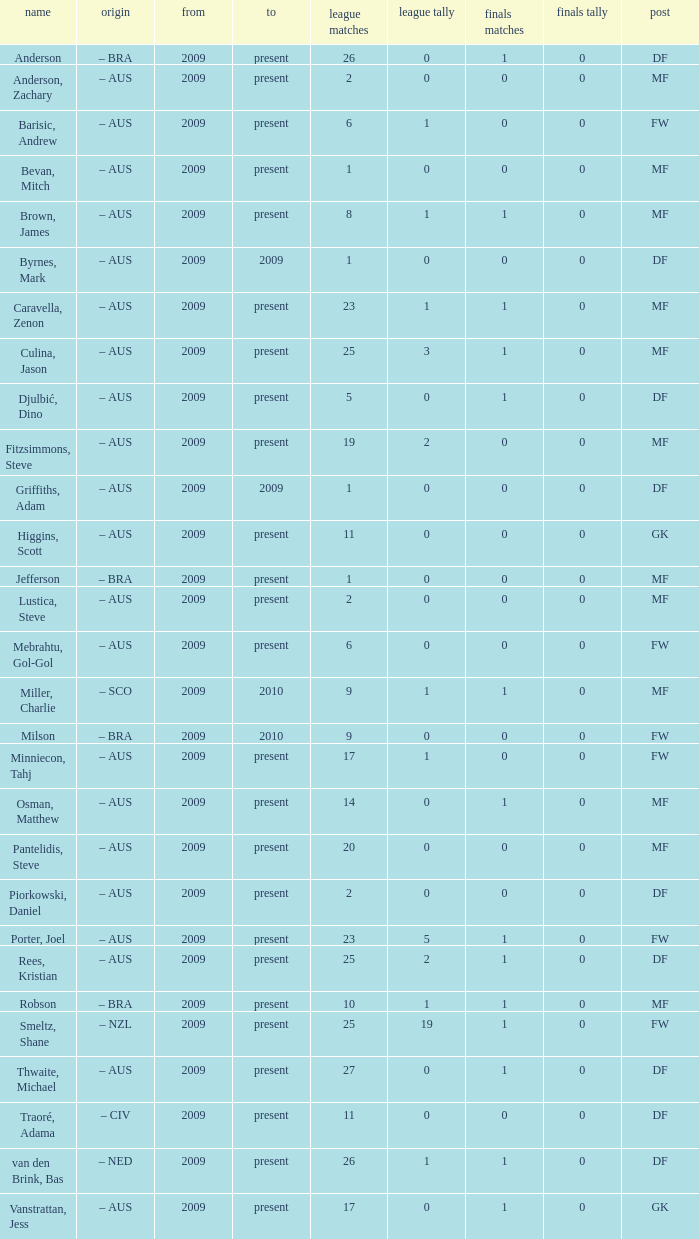Would you mind parsing the complete table? {'header': ['name', 'origin', 'from', 'to', 'league matches', 'league tally', 'finals matches', 'finals tally', 'post'], 'rows': [['Anderson', '– BRA', '2009', 'present', '26', '0', '1', '0', 'DF'], ['Anderson, Zachary', '– AUS', '2009', 'present', '2', '0', '0', '0', 'MF'], ['Barisic, Andrew', '– AUS', '2009', 'present', '6', '1', '0', '0', 'FW'], ['Bevan, Mitch', '– AUS', '2009', 'present', '1', '0', '0', '0', 'MF'], ['Brown, James', '– AUS', '2009', 'present', '8', '1', '1', '0', 'MF'], ['Byrnes, Mark', '– AUS', '2009', '2009', '1', '0', '0', '0', 'DF'], ['Caravella, Zenon', '– AUS', '2009', 'present', '23', '1', '1', '0', 'MF'], ['Culina, Jason', '– AUS', '2009', 'present', '25', '3', '1', '0', 'MF'], ['Djulbić, Dino', '– AUS', '2009', 'present', '5', '0', '1', '0', 'DF'], ['Fitzsimmons, Steve', '– AUS', '2009', 'present', '19', '2', '0', '0', 'MF'], ['Griffiths, Adam', '– AUS', '2009', '2009', '1', '0', '0', '0', 'DF'], ['Higgins, Scott', '– AUS', '2009', 'present', '11', '0', '0', '0', 'GK'], ['Jefferson', '– BRA', '2009', 'present', '1', '0', '0', '0', 'MF'], ['Lustica, Steve', '– AUS', '2009', 'present', '2', '0', '0', '0', 'MF'], ['Mebrahtu, Gol-Gol', '– AUS', '2009', 'present', '6', '0', '0', '0', 'FW'], ['Miller, Charlie', '– SCO', '2009', '2010', '9', '1', '1', '0', 'MF'], ['Milson', '– BRA', '2009', '2010', '9', '0', '0', '0', 'FW'], ['Minniecon, Tahj', '– AUS', '2009', 'present', '17', '1', '0', '0', 'FW'], ['Osman, Matthew', '– AUS', '2009', 'present', '14', '0', '1', '0', 'MF'], ['Pantelidis, Steve', '– AUS', '2009', 'present', '20', '0', '0', '0', 'MF'], ['Piorkowski, Daniel', '– AUS', '2009', 'present', '2', '0', '0', '0', 'DF'], ['Porter, Joel', '– AUS', '2009', 'present', '23', '5', '1', '0', 'FW'], ['Rees, Kristian', '– AUS', '2009', 'present', '25', '2', '1', '0', 'DF'], ['Robson', '– BRA', '2009', 'present', '10', '1', '1', '0', 'MF'], ['Smeltz, Shane', '– NZL', '2009', 'present', '25', '19', '1', '0', 'FW'], ['Thwaite, Michael', '– AUS', '2009', 'present', '27', '0', '1', '0', 'DF'], ['Traoré, Adama', '– CIV', '2009', 'present', '11', '0', '0', '0', 'DF'], ['van den Brink, Bas', '– NED', '2009', 'present', '26', '1', '1', '0', 'DF'], ['Vanstrattan, Jess', '– AUS', '2009', 'present', '17', '0', '1', '0', 'GK']]} Name the mosst finals apps 1.0. 